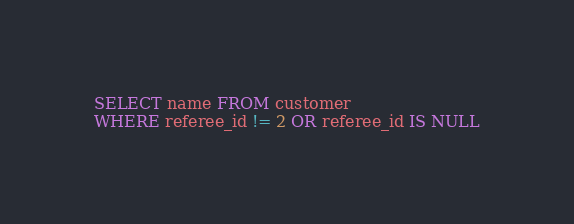<code> <loc_0><loc_0><loc_500><loc_500><_SQL_>SELECT name FROM customer
WHERE referee_id != 2 OR referee_id IS NULL
</code> 